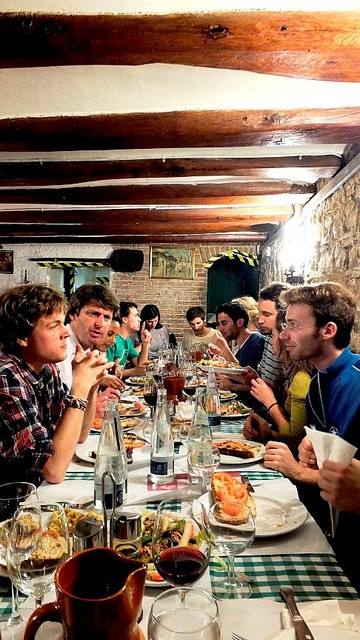Describe the objects in this image and their specific colors. I can see dining table in tan, black, beige, and darkgray tones, people in tan, black, maroon, and brown tones, people in tan, black, brown, maroon, and navy tones, cup in tan, black, maroon, and brown tones, and wine glass in tan and black tones in this image. 